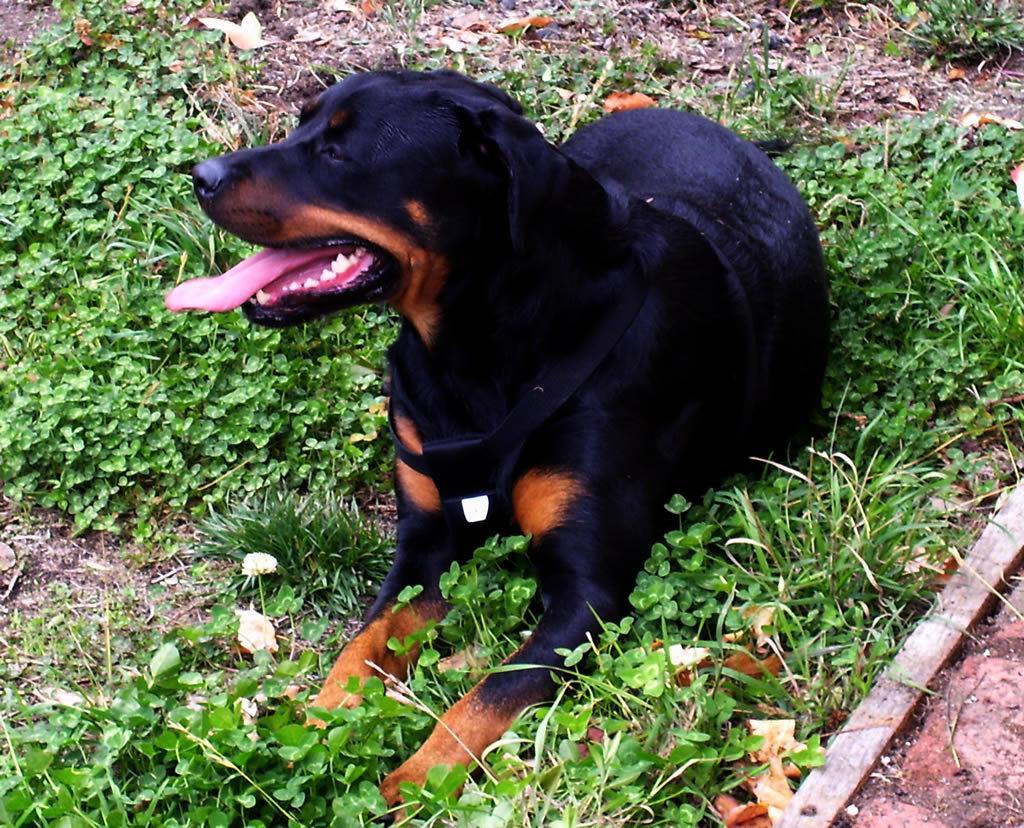Can you describe this image briefly? In this image we can see a dog on the ground, there are few plants and a wooden stick on the ground. 